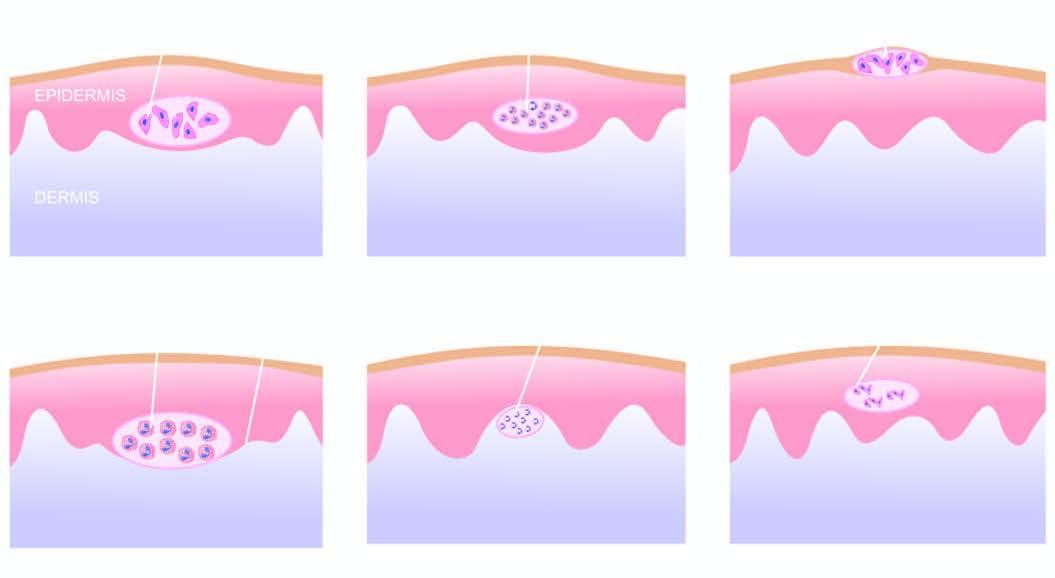what is there composed of neutrophils?
Answer the question using a single word or phrase. Papillary microabscess 